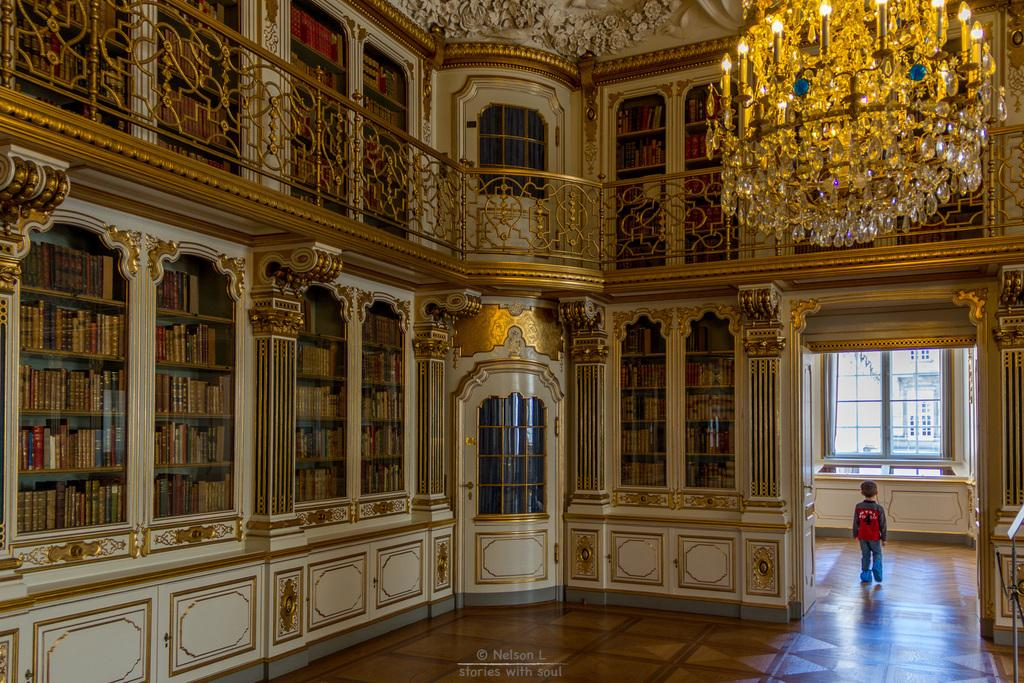What is the setting of the image? The image depicts the inside of a room. What can be seen on the racks in the room? There are books in the racks. What is the kid in the image doing? A kid is walking on the floor. What is providing illumination in the room? There are lights in the room. What hobbies is the kid participating in during the night in the image? The image does not specify the time of day, and there is no indication of any hobbies being practiced in the image. 